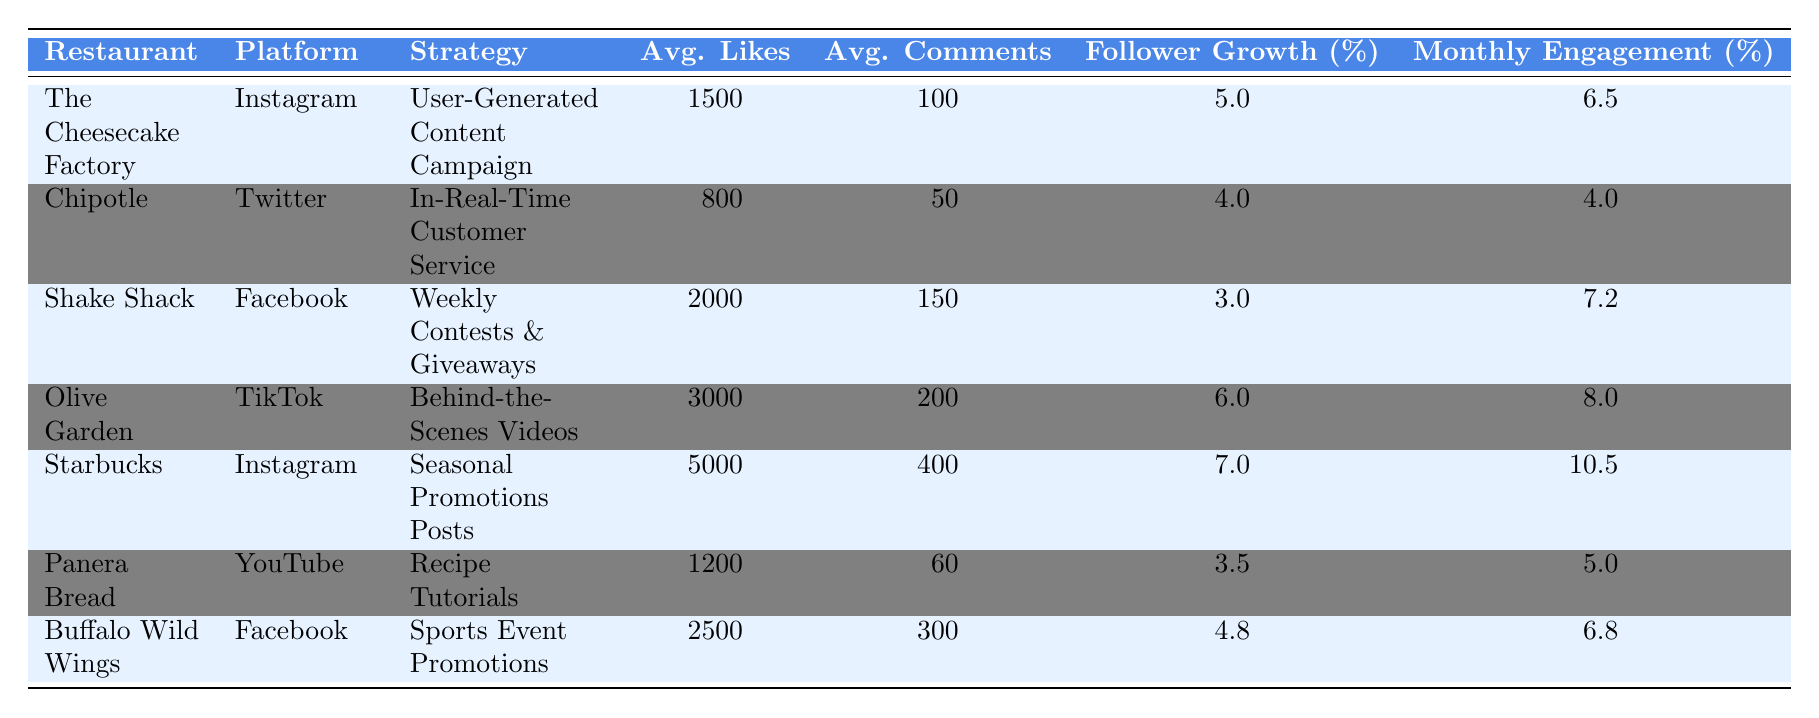What is the engagement strategy used by Olive Garden? According to the table, Olive Garden utilizes the "Behind-the-Scenes Videos" engagement strategy.
Answer: Behind-the-Scenes Videos Which restaurant has the highest average likes per post? The table shows that Starbucks has the highest average likes per post at 5000.
Answer: 5000 What is the follower growth rate of Shake Shack? From the table, Shake Shack has a follower growth rate of 3%.
Answer: 3% Calculate the average monthly engagement rate for all the restaurants listed. To find the average monthly engagement rate, add the engagement rates: 6.5 + 4.0 + 7.2 + 8.0 + 10.5 + 5.0 + 6.8 = 48.0. Divide this total by 7 (the number of restaurants): 48.0 / 7 = 6.857 (approximately).
Answer: 6.86 Is the average comments per post for Chipotle greater than 70? The table indicates that Chipotle has 50 average comments per post, which is not greater than 70.
Answer: False What is the difference in average likes between Starbucks and Panera Bread? Starbucks has 5000 average likes and Panera Bread has 1200 average likes. The difference is 5000 - 1200 = 3800.
Answer: 3800 Which restaurant has the third-highest monthly engagement rate? Looking at the engagement rates, Olive Garden has 8.0%, Starbucks has 10.5%, and Shake Shack has 7.2%. Therefore, Shake Shack is the third-highest.
Answer: Shake Shack What is the total average comments for all restaurants combined? Sum the average comments: 100 + 50 + 150 + 200 + 400 + 60 + 300 = 1260.
Answer: 1260 Is the average likes per post for Buffalo Wild Wings greater than that of Chipotle? Buffalo Wild Wings has 2500 average likes while Chipotle has 800. Since 2500 is greater than 800, the statement is true.
Answer: True Calculate the median monthly engagement rate among the restaurants. The monthly engagement rates are: 6.5, 4.0, 7.2, 8.0, 10.5, 5.0, 6.8. Sorting these gives: 4.0, 5.0, 6.5, 6.8, 7.2, 8.0, 10.5. The median is the middle value, which is 6.8.
Answer: 6.8 